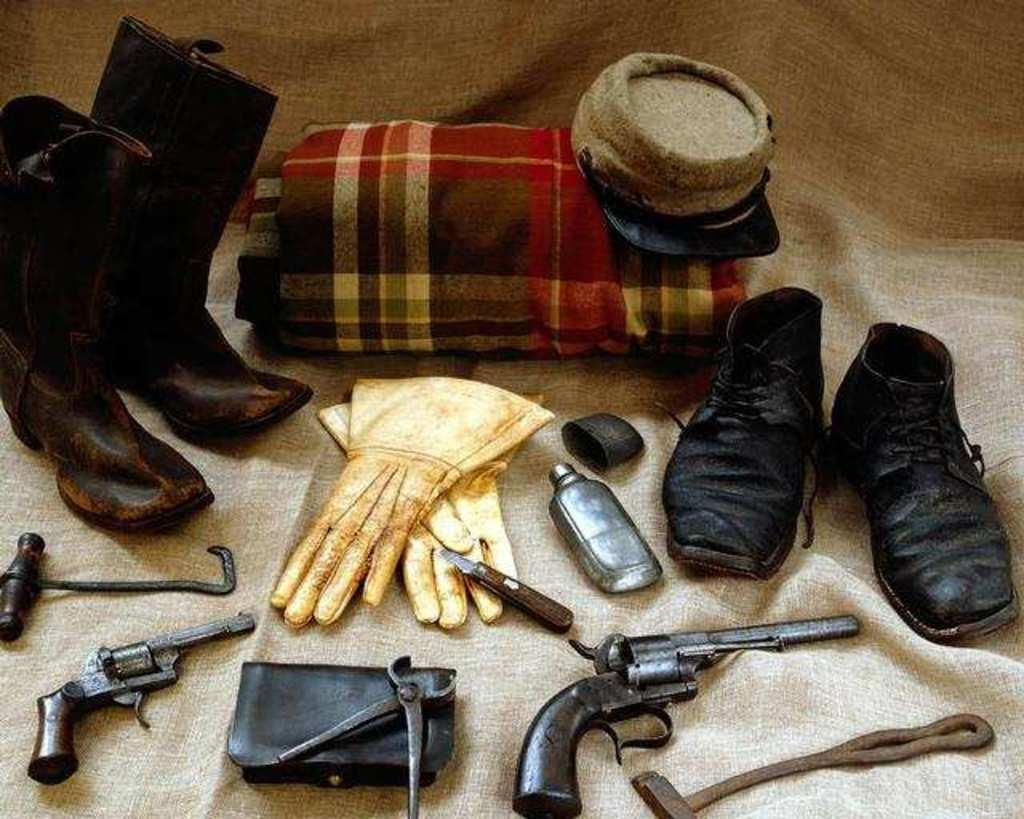What type of objects are on the carpet in the image? There are shoes, guns, gloves, a cap, and a blanket on the carpet in the image. Can you describe the arrangement of the objects on the carpet? The objects are placed on the carpet, but their specific arrangement is not mentioned in the facts. What type of flooring is visible in the image? The carpet is the flooring visible in the image. Are there any other unspecified objects on the carpet? Yes, there are other unspecified objects on the carpet in the image. How many bears are visible on the carpet in the image? There are no bears present in the image; the objects mentioned are shoes, guns, gloves, a cap, a blanket, and other unspecified objects. 